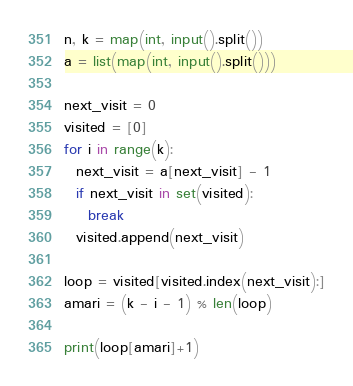<code> <loc_0><loc_0><loc_500><loc_500><_Python_>n, k = map(int, input().split())
a = list(map(int, input().split()))
 
next_visit = 0
visited = [0]
for i in range(k):
  next_visit = a[next_visit] - 1
  if next_visit in set(visited):
    break
  visited.append(next_visit)
 
loop = visited[visited.index(next_visit):]
amari = (k - i - 1) % len(loop)
 
print(loop[amari]+1)</code> 